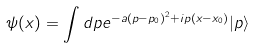<formula> <loc_0><loc_0><loc_500><loc_500>\psi ( x ) = \int d p e ^ { - a ( p - p _ { 0 } ) ^ { 2 } + i p ( x - x _ { 0 } ) } | p \rangle</formula> 